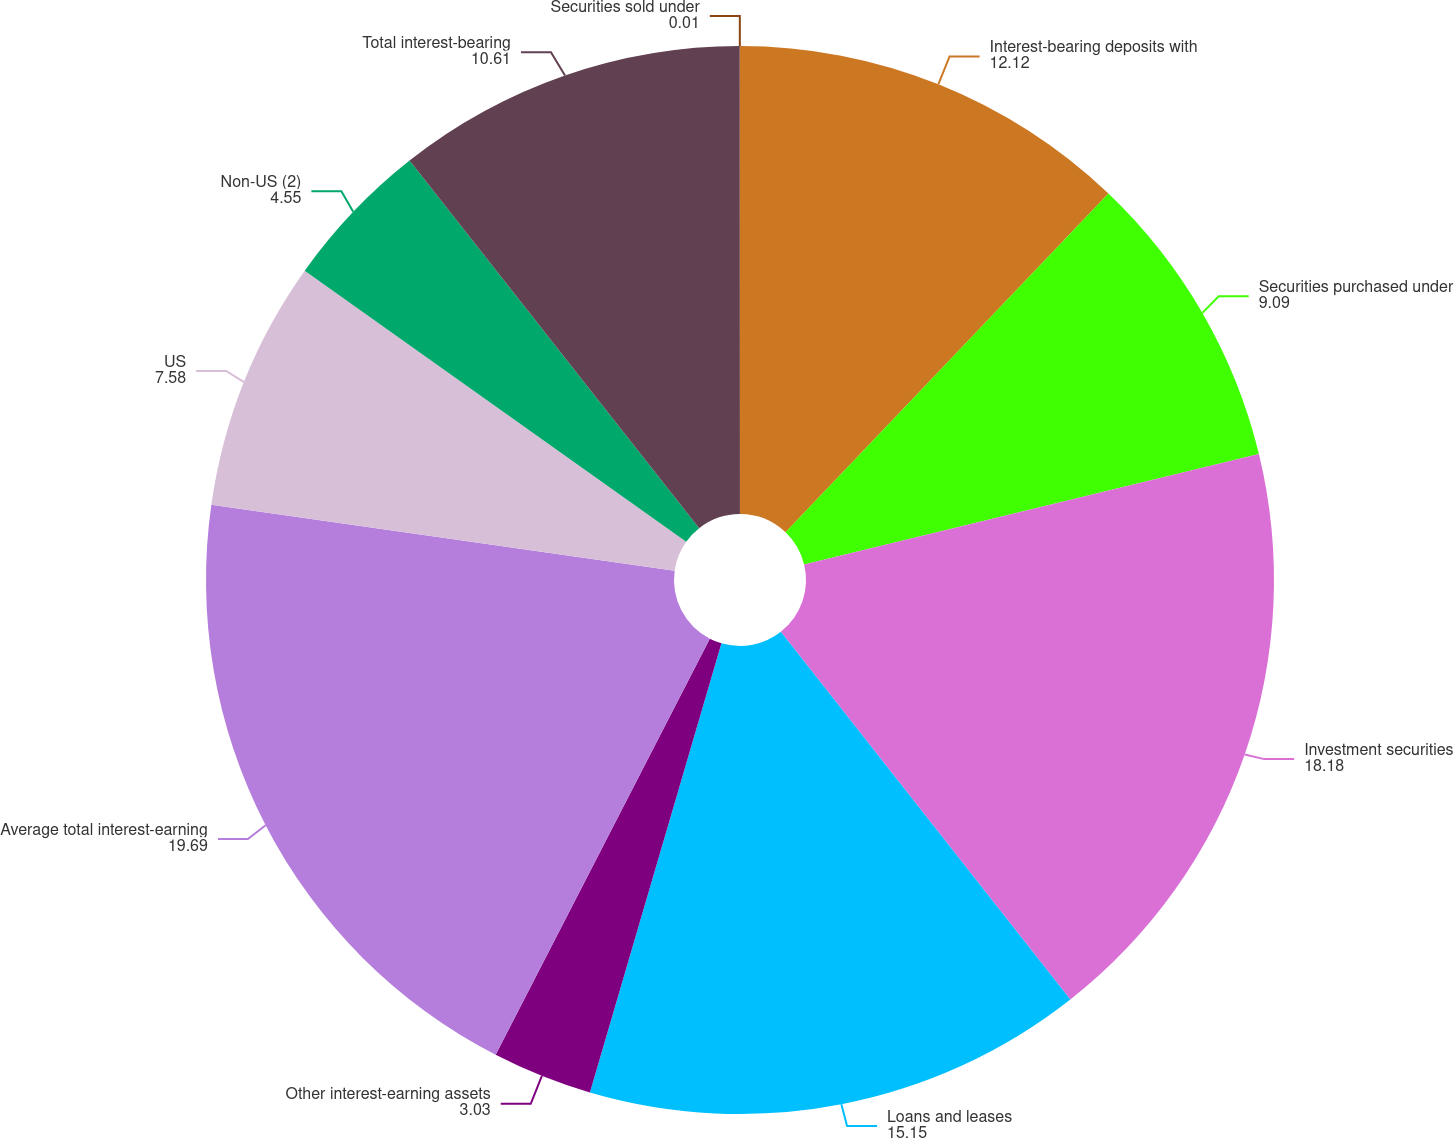Convert chart to OTSL. <chart><loc_0><loc_0><loc_500><loc_500><pie_chart><fcel>Interest-bearing deposits with<fcel>Securities purchased under<fcel>Investment securities<fcel>Loans and leases<fcel>Other interest-earning assets<fcel>Average total interest-earning<fcel>US<fcel>Non-US (2)<fcel>Total interest-bearing<fcel>Securities sold under<nl><fcel>12.12%<fcel>9.09%<fcel>18.18%<fcel>15.15%<fcel>3.03%<fcel>19.69%<fcel>7.58%<fcel>4.55%<fcel>10.61%<fcel>0.01%<nl></chart> 